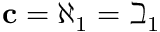Convert formula to latex. <formula><loc_0><loc_0><loc_500><loc_500>c = \aleph _ { 1 } = \beth _ { 1 }</formula> 